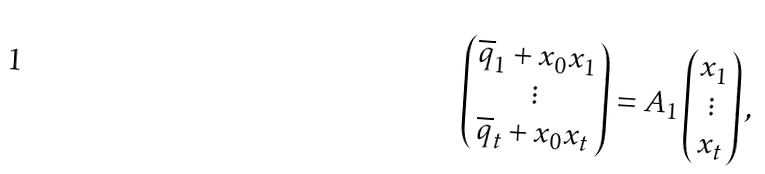<formula> <loc_0><loc_0><loc_500><loc_500>\left ( \begin{matrix} \overline { q } _ { 1 } + x _ { 0 } x _ { 1 } \\ \vdots \\ \overline { q } _ { t } + x _ { 0 } x _ { t } \end{matrix} \right ) = A _ { 1 } \left ( \begin{matrix} x _ { 1 } \\ \vdots \\ x _ { t } \end{matrix} \right ) ,</formula> 